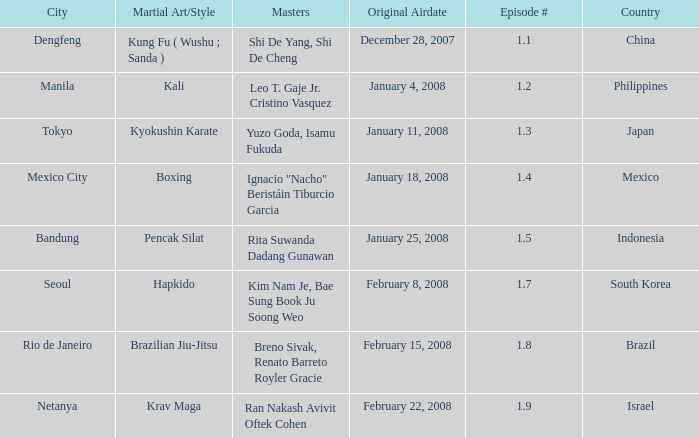Which masters fought in hapkido style? Kim Nam Je, Bae Sung Book Ju Soong Weo. 